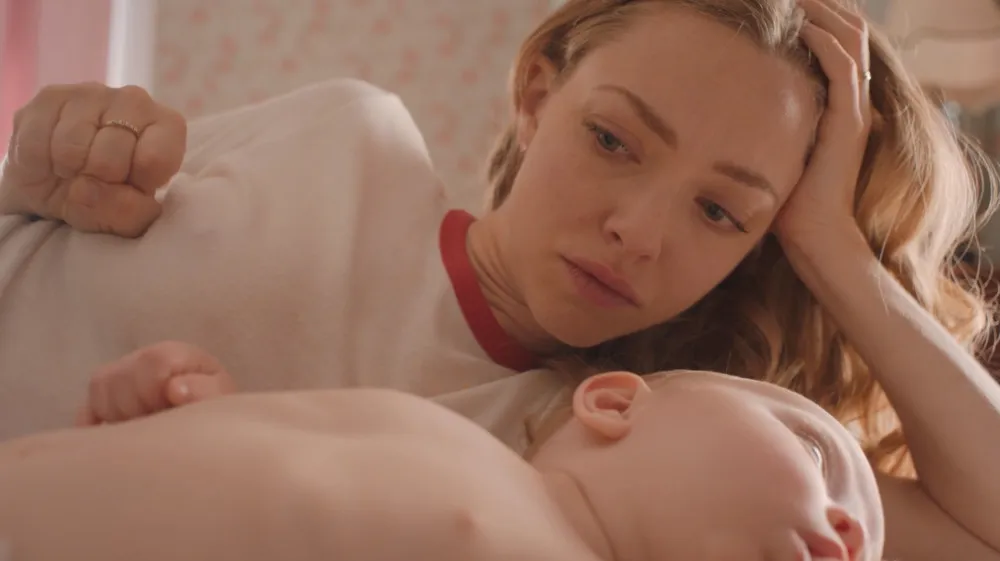Can you elaborate on the elements of the picture provided? The image features a woman with a contemplative expression lying on a bed beside a sleeping baby. The room has floral wallpaper, predominantly in shades of pink, which adds a soft, serene backdrop to the scene. The woman, dressed in a white sweater, has her hand resting gently on her head, suggesting deep thought or concern. The baby, in a white onesie, lies peacefully beside her, portraying a tranquil moment of rest. This tableau beautifully captures the intimacy and reflective quietude of motherhood. 